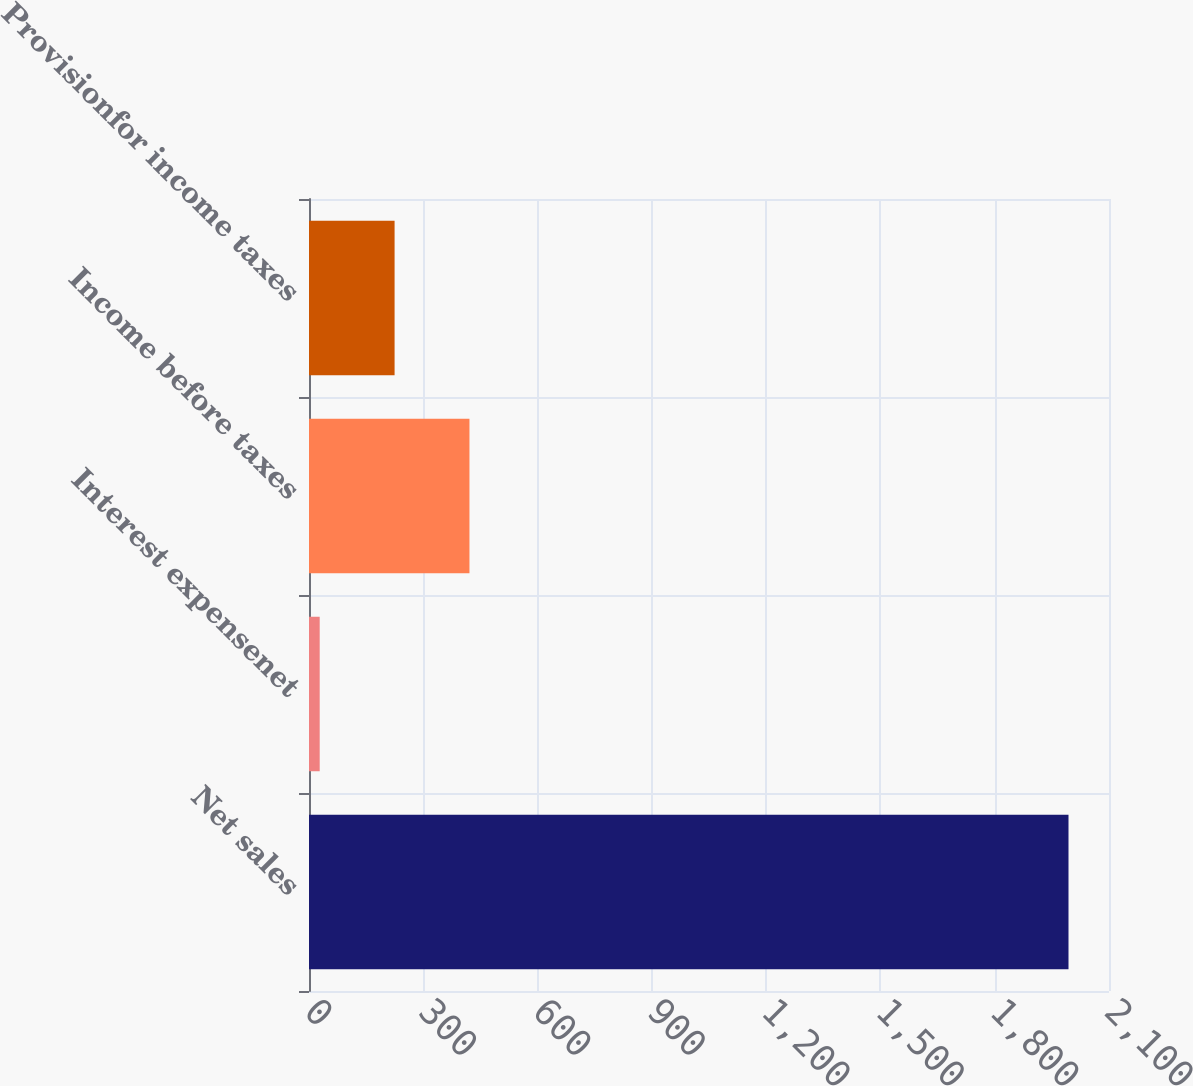Convert chart. <chart><loc_0><loc_0><loc_500><loc_500><bar_chart><fcel>Net sales<fcel>Interest expensenet<fcel>Income before taxes<fcel>Provisionfor income taxes<nl><fcel>1993.7<fcel>28.1<fcel>421.22<fcel>224.66<nl></chart> 